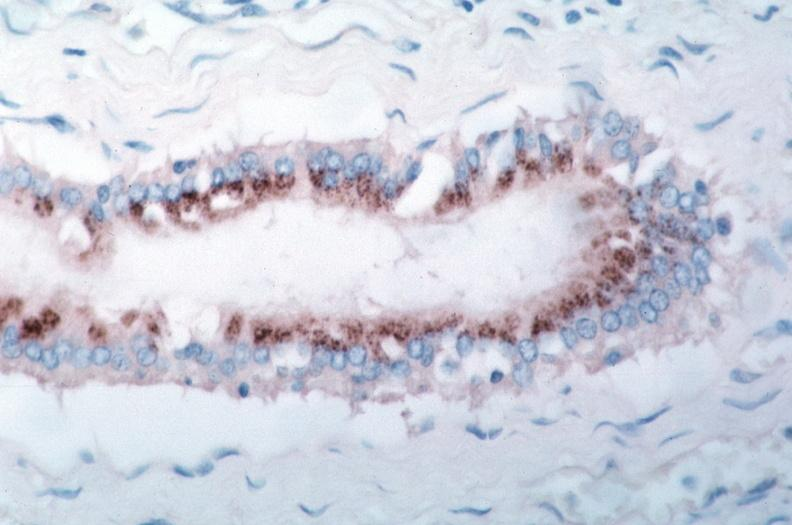s cardiovascular present?
Answer the question using a single word or phrase. Yes 